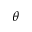<formula> <loc_0><loc_0><loc_500><loc_500>\theta</formula> 